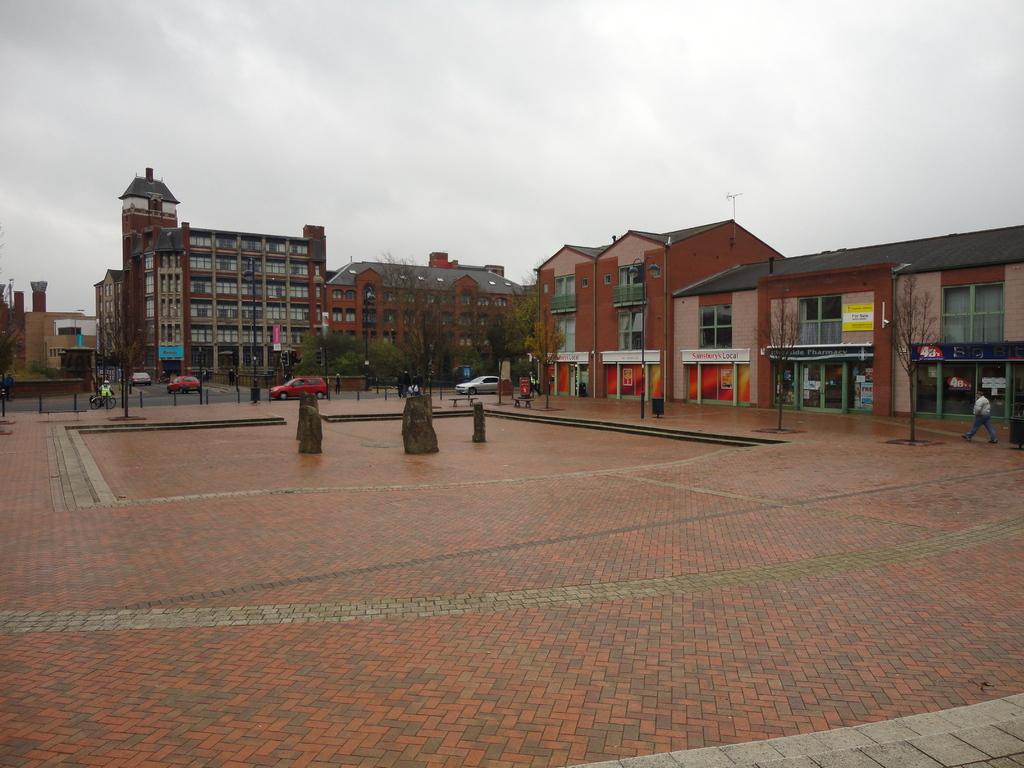How would you summarize this image in a sentence or two? At the bottom of the image there is a floor. In the middle of the floor there are statues. And also there are poles. Behind the poles there is a road with vehicles. And also there are trees. And in the image there are buildings with walls, windows, roofs and chimneys. And also there are stores with glass doors and name boards. At the top of the image there is sky with clouds. 